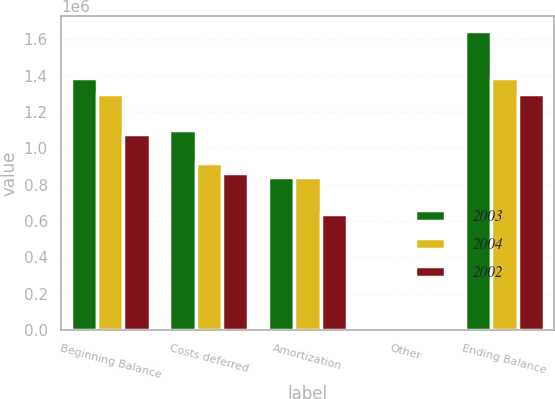Convert chart. <chart><loc_0><loc_0><loc_500><loc_500><stacked_bar_chart><ecel><fcel>Beginning Balance<fcel>Costs deferred<fcel>Amortization<fcel>Other<fcel>Ending Balance<nl><fcel>2003<fcel>1.38483e+06<fcel>1.10106e+06<fcel>841096<fcel>2858<fcel>1.64765e+06<nl><fcel>2004<fcel>1.2988e+06<fcel>921385<fcel>839799<fcel>4444<fcel>1.38483e+06<nl><fcel>2002<fcel>1.0763e+06<fcel>862078<fcel>638298<fcel>1283<fcel>1.2988e+06<nl></chart> 